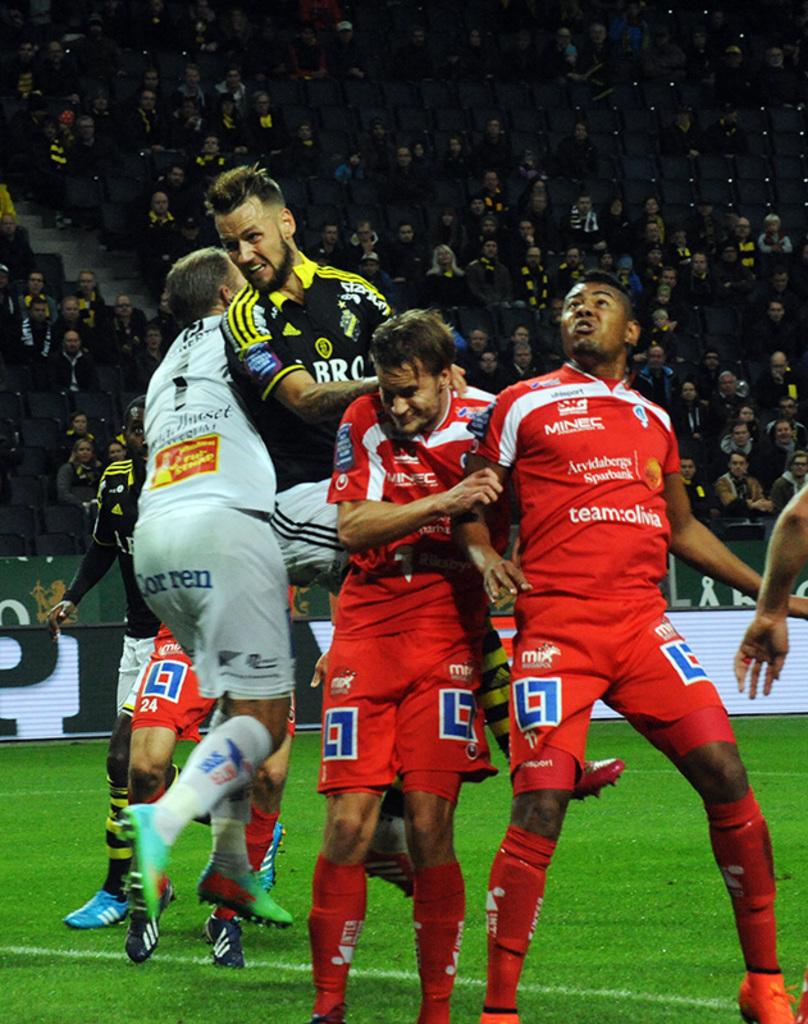What accent color is used with the red uniforms?
Your answer should be very brief. White. 